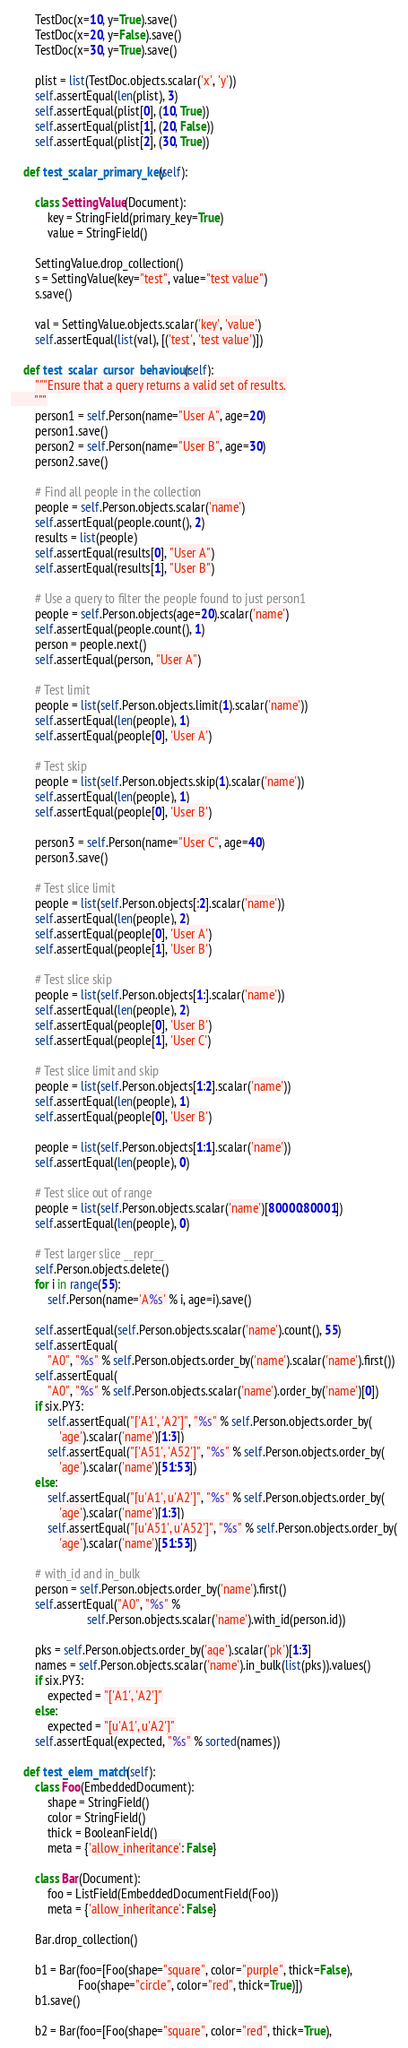Convert code to text. <code><loc_0><loc_0><loc_500><loc_500><_Python_>
        TestDoc(x=10, y=True).save()
        TestDoc(x=20, y=False).save()
        TestDoc(x=30, y=True).save()

        plist = list(TestDoc.objects.scalar('x', 'y'))
        self.assertEqual(len(plist), 3)
        self.assertEqual(plist[0], (10, True))
        self.assertEqual(plist[1], (20, False))
        self.assertEqual(plist[2], (30, True))

    def test_scalar_primary_key(self):

        class SettingValue(Document):
            key = StringField(primary_key=True)
            value = StringField()

        SettingValue.drop_collection()
        s = SettingValue(key="test", value="test value")
        s.save()

        val = SettingValue.objects.scalar('key', 'value')
        self.assertEqual(list(val), [('test', 'test value')])

    def test_scalar_cursor_behaviour(self):
        """Ensure that a query returns a valid set of results.
        """
        person1 = self.Person(name="User A", age=20)
        person1.save()
        person2 = self.Person(name="User B", age=30)
        person2.save()

        # Find all people in the collection
        people = self.Person.objects.scalar('name')
        self.assertEqual(people.count(), 2)
        results = list(people)
        self.assertEqual(results[0], "User A")
        self.assertEqual(results[1], "User B")

        # Use a query to filter the people found to just person1
        people = self.Person.objects(age=20).scalar('name')
        self.assertEqual(people.count(), 1)
        person = people.next()
        self.assertEqual(person, "User A")

        # Test limit
        people = list(self.Person.objects.limit(1).scalar('name'))
        self.assertEqual(len(people), 1)
        self.assertEqual(people[0], 'User A')

        # Test skip
        people = list(self.Person.objects.skip(1).scalar('name'))
        self.assertEqual(len(people), 1)
        self.assertEqual(people[0], 'User B')

        person3 = self.Person(name="User C", age=40)
        person3.save()

        # Test slice limit
        people = list(self.Person.objects[:2].scalar('name'))
        self.assertEqual(len(people), 2)
        self.assertEqual(people[0], 'User A')
        self.assertEqual(people[1], 'User B')

        # Test slice skip
        people = list(self.Person.objects[1:].scalar('name'))
        self.assertEqual(len(people), 2)
        self.assertEqual(people[0], 'User B')
        self.assertEqual(people[1], 'User C')

        # Test slice limit and skip
        people = list(self.Person.objects[1:2].scalar('name'))
        self.assertEqual(len(people), 1)
        self.assertEqual(people[0], 'User B')

        people = list(self.Person.objects[1:1].scalar('name'))
        self.assertEqual(len(people), 0)

        # Test slice out of range
        people = list(self.Person.objects.scalar('name')[80000:80001])
        self.assertEqual(len(people), 0)

        # Test larger slice __repr__
        self.Person.objects.delete()
        for i in range(55):
            self.Person(name='A%s' % i, age=i).save()

        self.assertEqual(self.Person.objects.scalar('name').count(), 55)
        self.assertEqual(
            "A0", "%s" % self.Person.objects.order_by('name').scalar('name').first())
        self.assertEqual(
            "A0", "%s" % self.Person.objects.scalar('name').order_by('name')[0])
        if six.PY3:
            self.assertEqual("['A1', 'A2']", "%s" % self.Person.objects.order_by(
                'age').scalar('name')[1:3])
            self.assertEqual("['A51', 'A52']", "%s" % self.Person.objects.order_by(
                'age').scalar('name')[51:53])
        else:
            self.assertEqual("[u'A1', u'A2']", "%s" % self.Person.objects.order_by(
                'age').scalar('name')[1:3])
            self.assertEqual("[u'A51', u'A52']", "%s" % self.Person.objects.order_by(
                'age').scalar('name')[51:53])

        # with_id and in_bulk
        person = self.Person.objects.order_by('name').first()
        self.assertEqual("A0", "%s" %
                         self.Person.objects.scalar('name').with_id(person.id))

        pks = self.Person.objects.order_by('age').scalar('pk')[1:3]
        names = self.Person.objects.scalar('name').in_bulk(list(pks)).values()
        if six.PY3:
            expected = "['A1', 'A2']"
        else:
            expected = "[u'A1', u'A2']"
        self.assertEqual(expected, "%s" % sorted(names))

    def test_elem_match(self):
        class Foo(EmbeddedDocument):
            shape = StringField()
            color = StringField()
            thick = BooleanField()
            meta = {'allow_inheritance': False}

        class Bar(Document):
            foo = ListField(EmbeddedDocumentField(Foo))
            meta = {'allow_inheritance': False}

        Bar.drop_collection()

        b1 = Bar(foo=[Foo(shape="square", color="purple", thick=False),
                      Foo(shape="circle", color="red", thick=True)])
        b1.save()

        b2 = Bar(foo=[Foo(shape="square", color="red", thick=True),</code> 